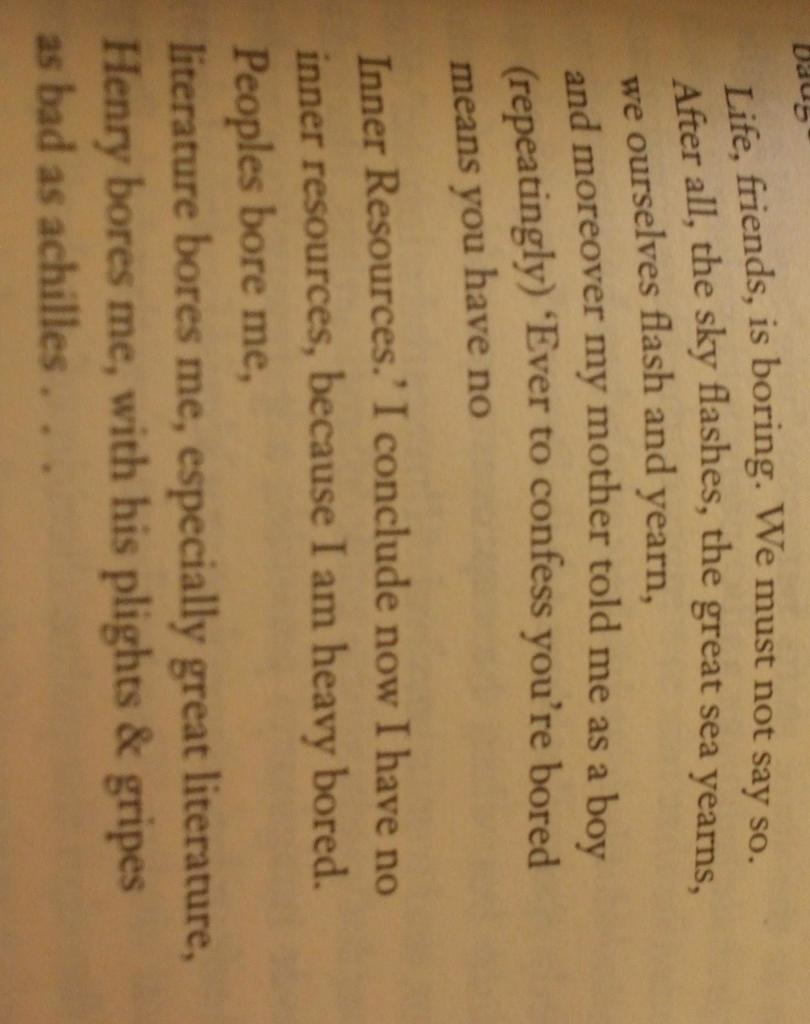<image>
Relay a brief, clear account of the picture shown. A book is open to a page discussing Inner Resources. 